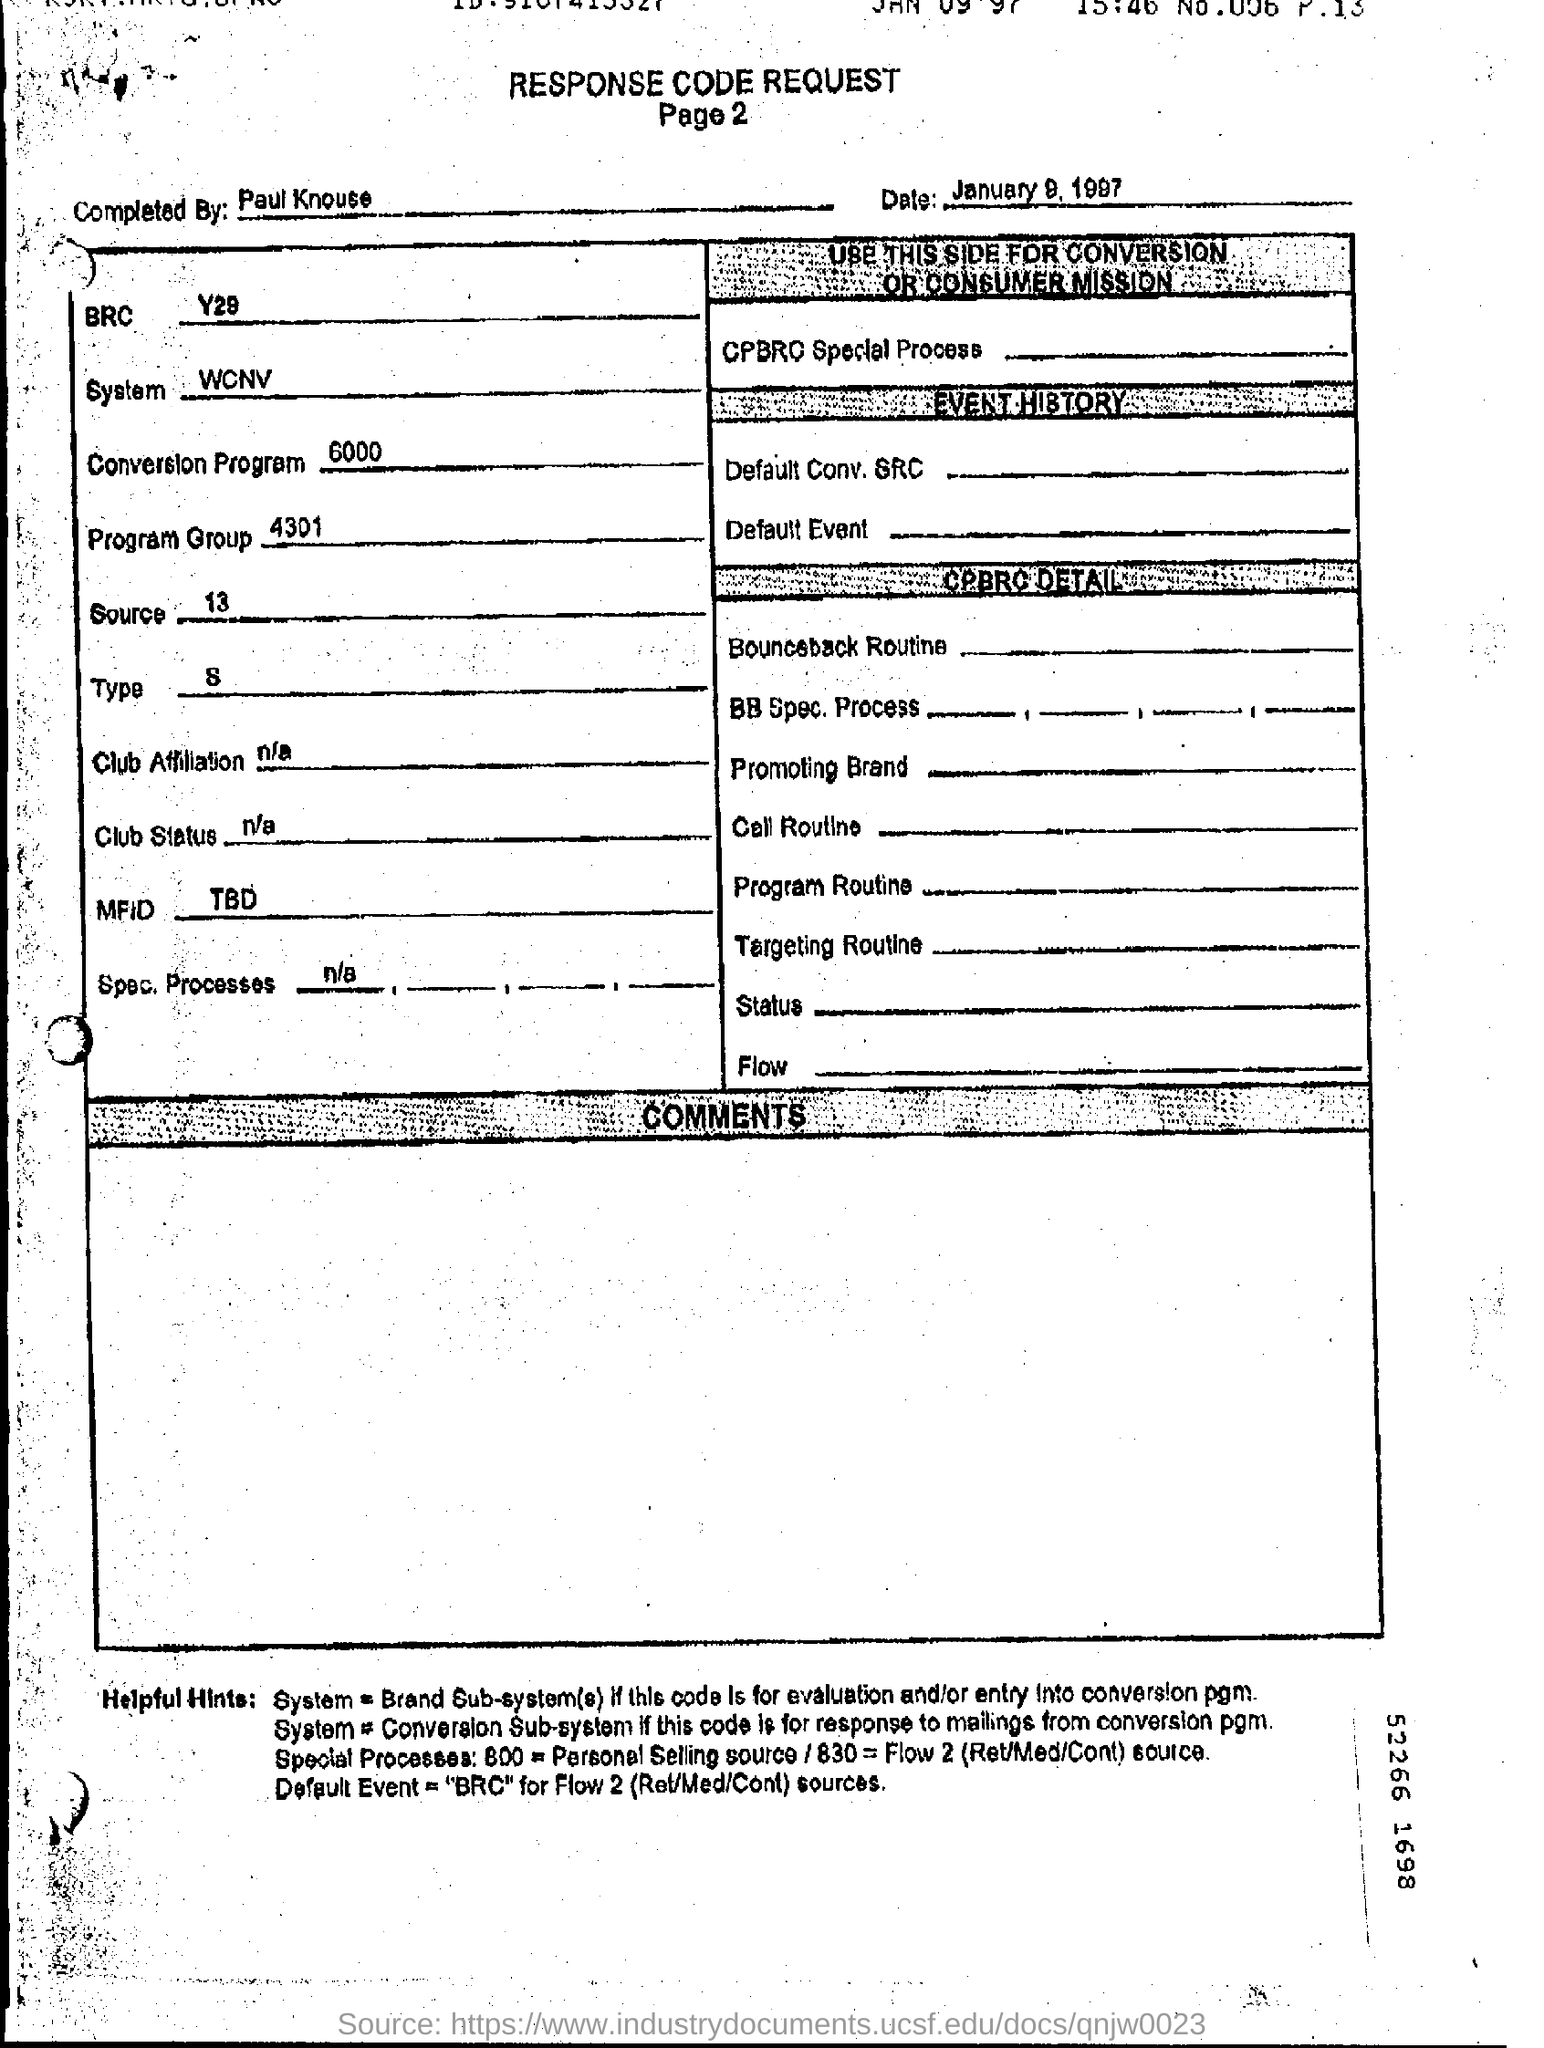List a handful of essential elements in this visual. The date mentioned is January 9, 1997. 